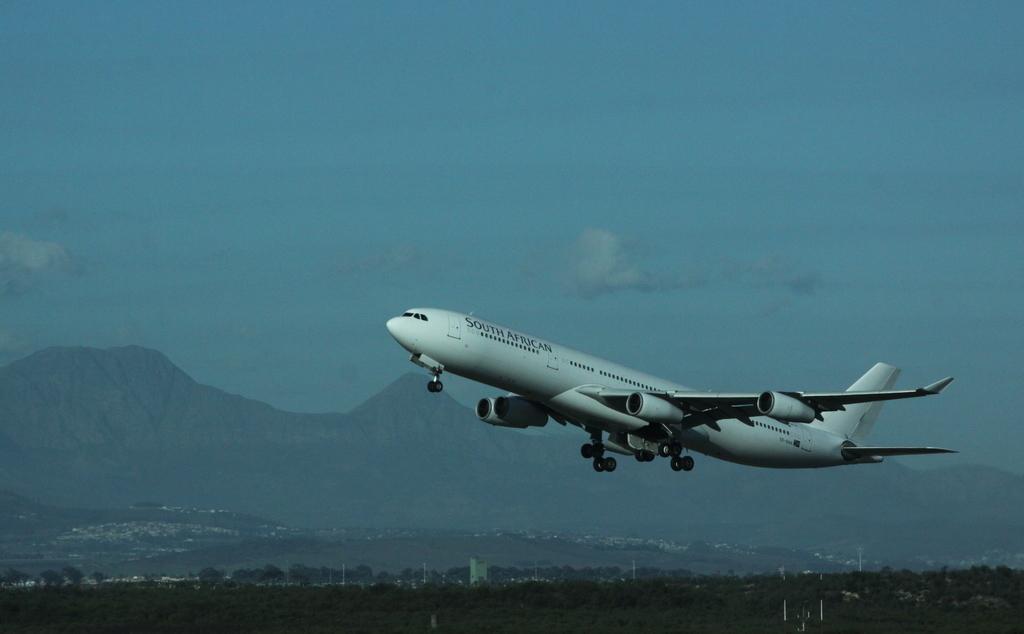Describe this image in one or two sentences. In this image we can see an airplane flying, on the bottom of the picture we can see few trees and in the background there are mountains and the sky. 